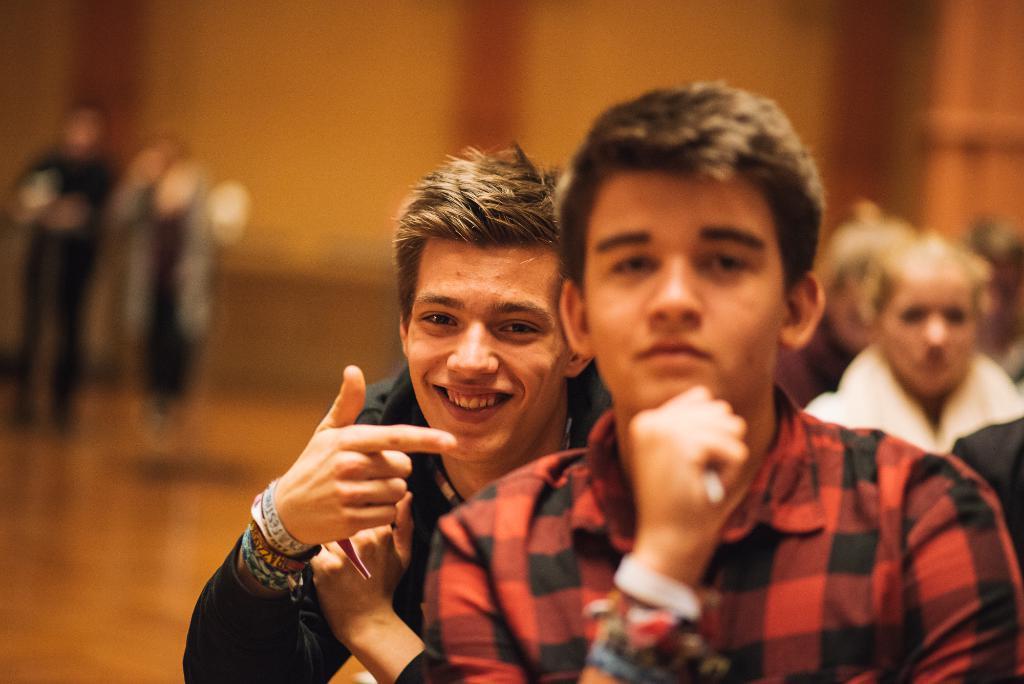Could you give a brief overview of what you see in this image? In this image I can see a person sitting in the front, wearing a red and black checked shirt. There is another person behind him, he is smiling and showing his index finger. The background is blurred. 